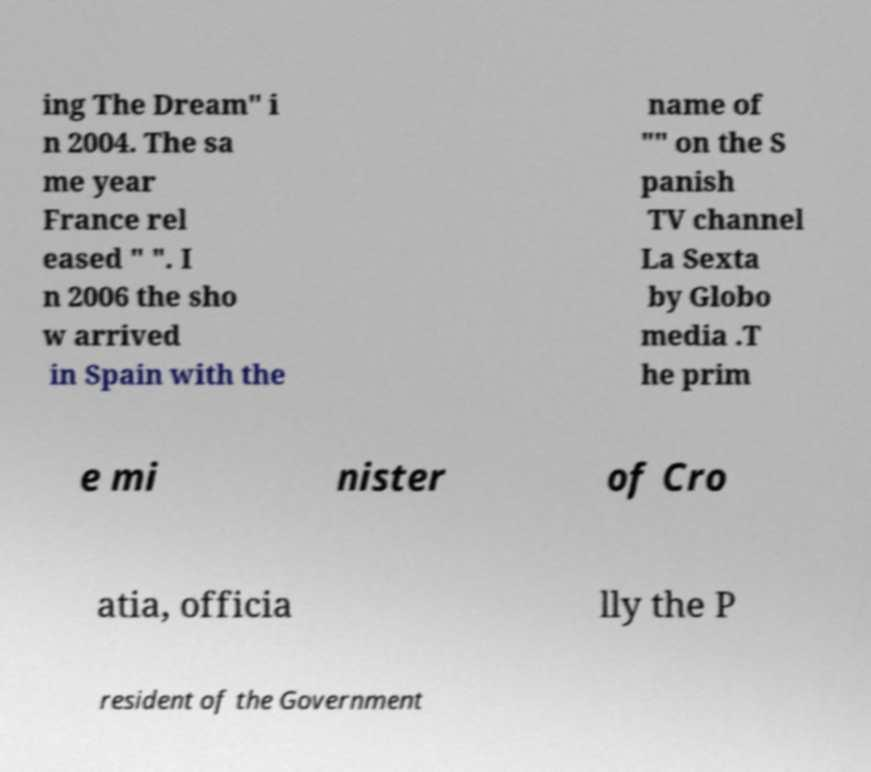Can you read and provide the text displayed in the image?This photo seems to have some interesting text. Can you extract and type it out for me? ing The Dream" i n 2004. The sa me year France rel eased " ". I n 2006 the sho w arrived in Spain with the name of "" on the S panish TV channel La Sexta by Globo media .T he prim e mi nister of Cro atia, officia lly the P resident of the Government 